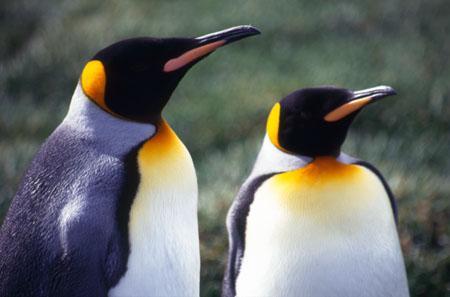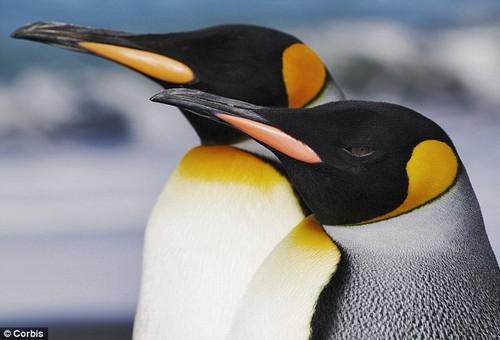The first image is the image on the left, the second image is the image on the right. Considering the images on both sides, is "There are four penguins in total." valid? Answer yes or no. Yes. The first image is the image on the left, the second image is the image on the right. For the images shown, is this caption "Each image shows exactly two penguins posed close together." true? Answer yes or no. Yes. 